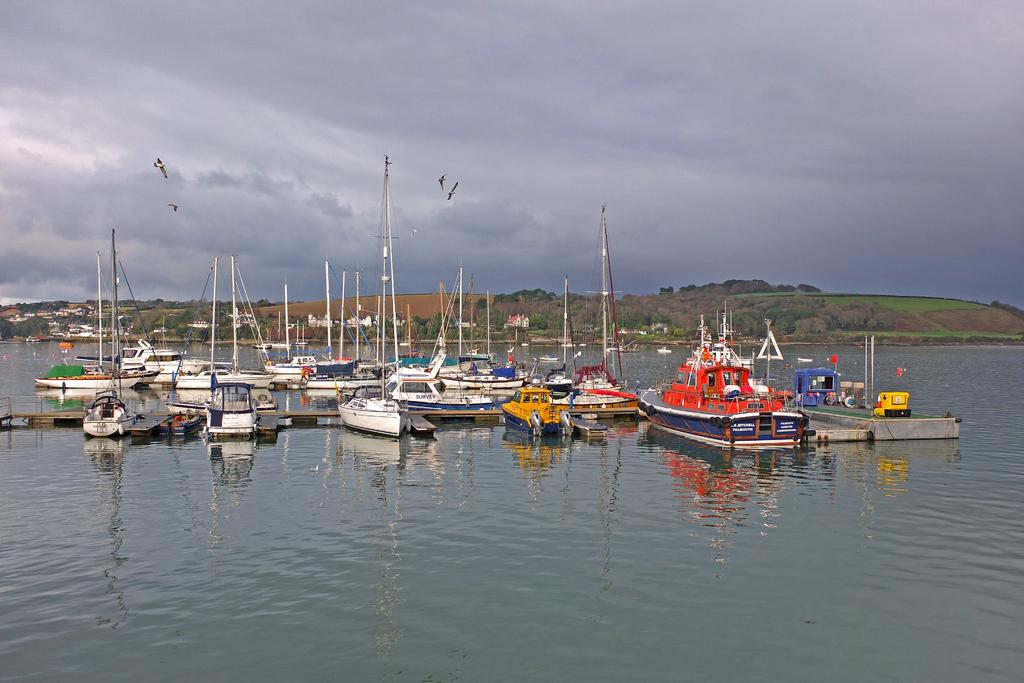What is floating on the water in the image? There are boats on the surface of the water in the image. What is the primary element visible in the image? Water is visible in the image. What can be seen in the background of the image? There are trees and the sky visible in the background of the image. How would you describe the sky in the image? The sky appears to be cloudy in the image. What type of marble is being used to build the fowl in the image? There is no marble or fowl present in the image; it features boats on the water with trees and a cloudy sky in the background. 